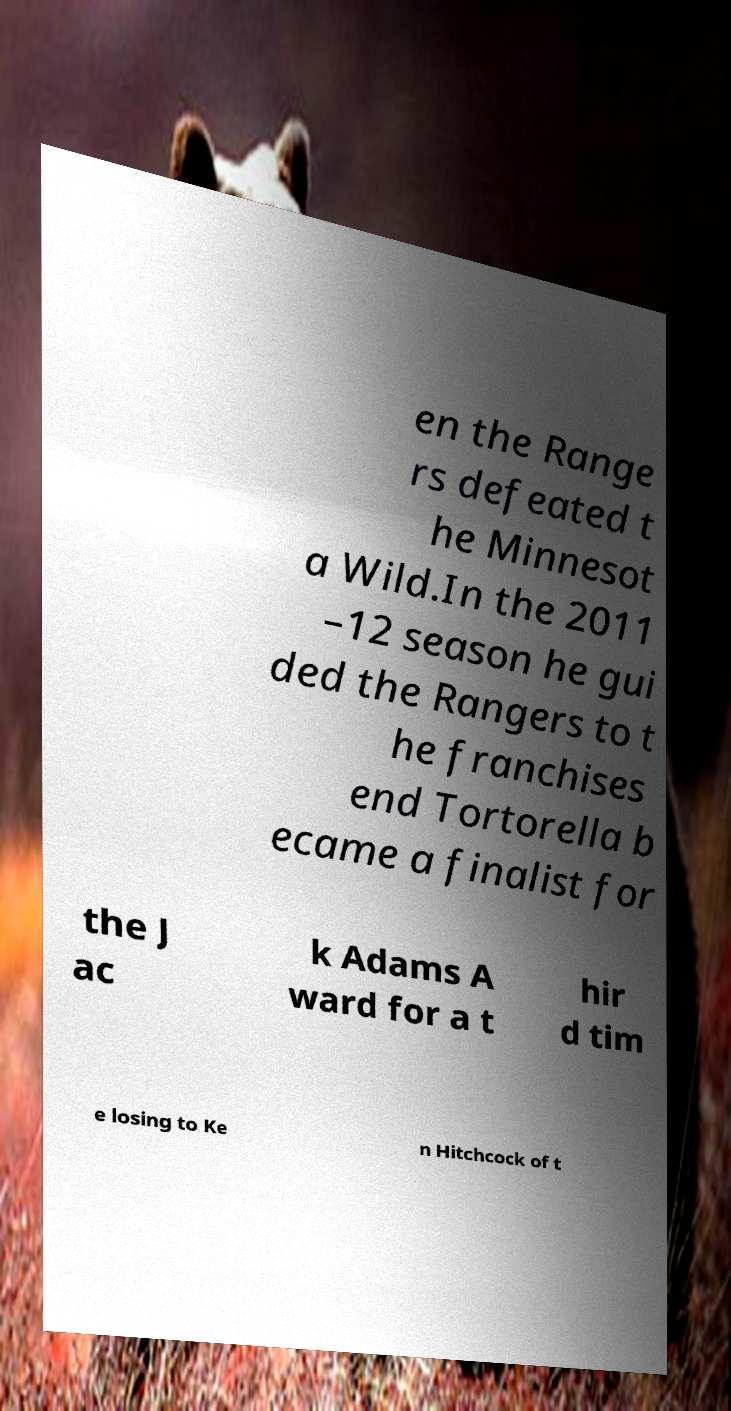Could you assist in decoding the text presented in this image and type it out clearly? en the Range rs defeated t he Minnesot a Wild.In the 2011 –12 season he gui ded the Rangers to t he franchises end Tortorella b ecame a finalist for the J ac k Adams A ward for a t hir d tim e losing to Ke n Hitchcock of t 